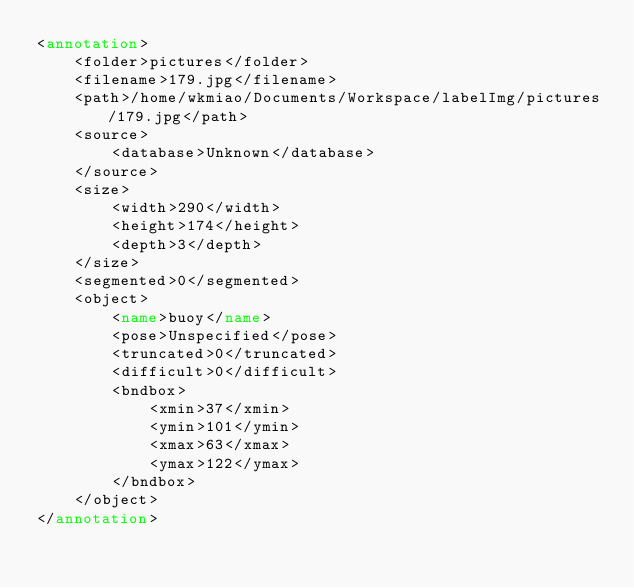Convert code to text. <code><loc_0><loc_0><loc_500><loc_500><_XML_><annotation>
	<folder>pictures</folder>
	<filename>179.jpg</filename>
	<path>/home/wkmiao/Documents/Workspace/labelImg/pictures/179.jpg</path>
	<source>
		<database>Unknown</database>
	</source>
	<size>
		<width>290</width>
		<height>174</height>
		<depth>3</depth>
	</size>
	<segmented>0</segmented>
	<object>
		<name>buoy</name>
		<pose>Unspecified</pose>
		<truncated>0</truncated>
		<difficult>0</difficult>
		<bndbox>
			<xmin>37</xmin>
			<ymin>101</ymin>
			<xmax>63</xmax>
			<ymax>122</ymax>
		</bndbox>
	</object>
</annotation>
</code> 